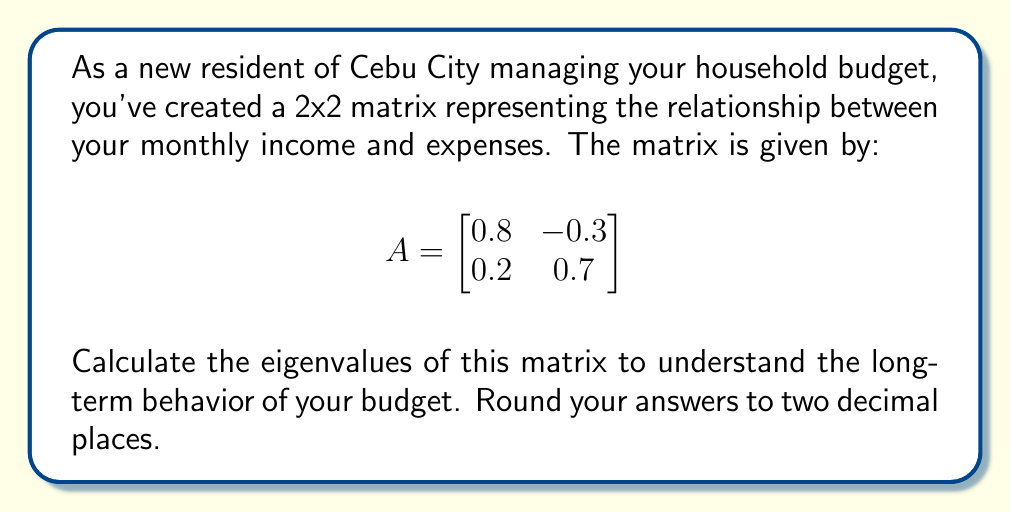Provide a solution to this math problem. To find the eigenvalues of the 2x2 matrix A, we need to follow these steps:

1) The characteristic equation for eigenvalues is given by:
   $$det(A - \lambda I) = 0$$
   where $\lambda$ represents the eigenvalues and I is the 2x2 identity matrix.

2) Expand this equation:
   $$\begin{vmatrix}
   0.8 - \lambda & -0.3 \\
   0.2 & 0.7 - \lambda
   \end{vmatrix} = 0$$

3) Calculate the determinant:
   $$(0.8 - \lambda)(0.7 - \lambda) - (-0.3)(0.2) = 0$$

4) Simplify:
   $$0.56 - 0.8\lambda - 0.7\lambda + \lambda^2 + 0.06 = 0$$
   $$\lambda^2 - 1.5\lambda + 0.62 = 0$$

5) This is a quadratic equation. We can solve it using the quadratic formula:
   $$\lambda = \frac{-b \pm \sqrt{b^2 - 4ac}}{2a}$$
   where $a = 1$, $b = -1.5$, and $c = 0.62$

6) Substituting these values:
   $$\lambda = \frac{1.5 \pm \sqrt{(-1.5)^2 - 4(1)(0.62)}}{2(1)}$$
   $$\lambda = \frac{1.5 \pm \sqrt{2.25 - 2.48}}{2}$$
   $$\lambda = \frac{1.5 \pm \sqrt{-0.23}}{2}$$

7) Since the discriminant is negative, we have complex eigenvalues:
   $$\lambda = \frac{1.5 \pm i\sqrt{0.23}}{2}$$

8) Simplifying and rounding to two decimal places:
   $$\lambda_1 = 0.75 + 0.24i$$
   $$\lambda_2 = 0.75 - 0.24i$$
Answer: $\lambda_1 = 0.75 + 0.24i$, $\lambda_2 = 0.75 - 0.24i$ 